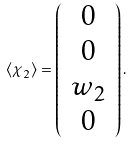<formula> <loc_0><loc_0><loc_500><loc_500>\langle \chi _ { 2 } \rangle = \left ( \begin{array} { c } 0 \\ 0 \\ w _ { 2 } \\ 0 \end{array} \right ) .</formula> 